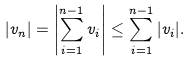Convert formula to latex. <formula><loc_0><loc_0><loc_500><loc_500>| v _ { n } | = \left | \sum _ { i = 1 } ^ { n - 1 } v _ { i } \right | \leq \sum _ { i = 1 } ^ { n - 1 } | v _ { i } | .</formula> 